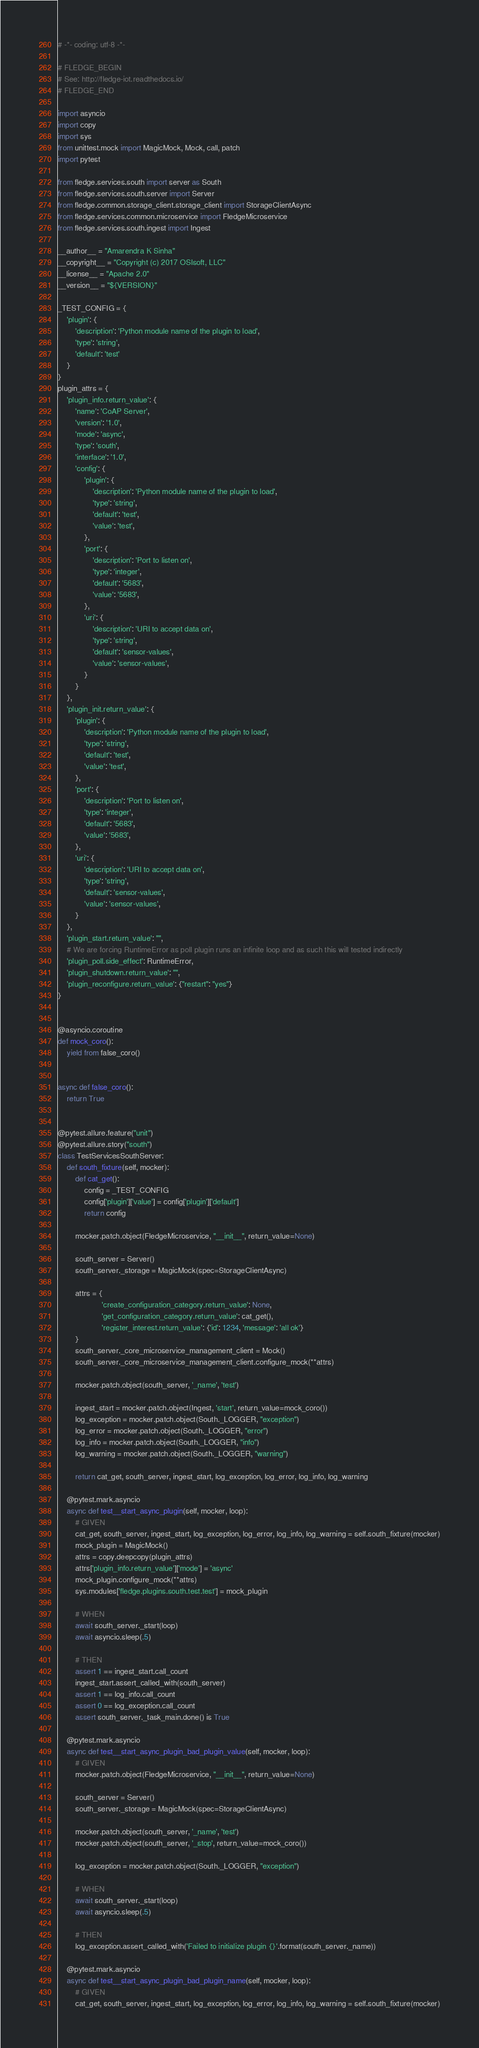Convert code to text. <code><loc_0><loc_0><loc_500><loc_500><_Python_># -*- coding: utf-8 -*-

# FLEDGE_BEGIN
# See: http://fledge-iot.readthedocs.io/
# FLEDGE_END

import asyncio
import copy
import sys
from unittest.mock import MagicMock, Mock, call, patch
import pytest

from fledge.services.south import server as South
from fledge.services.south.server import Server
from fledge.common.storage_client.storage_client import StorageClientAsync
from fledge.services.common.microservice import FledgeMicroservice
from fledge.services.south.ingest import Ingest

__author__ = "Amarendra K Sinha"
__copyright__ = "Copyright (c) 2017 OSIsoft, LLC"
__license__ = "Apache 2.0"
__version__ = "${VERSION}"

_TEST_CONFIG = {
    'plugin': {
        'description': 'Python module name of the plugin to load',
        'type': 'string',
        'default': 'test'
    }
}
plugin_attrs = {
    'plugin_info.return_value': {
        'name': 'CoAP Server',
        'version': '1.0',
        'mode': 'async',
        'type': 'south',
        'interface': '1.0',
        'config': {
            'plugin': {
                'description': 'Python module name of the plugin to load',
                'type': 'string',
                'default': 'test',
                'value': 'test',
            },
            'port': {
                'description': 'Port to listen on',
                'type': 'integer',
                'default': '5683',
                'value': '5683',
            },
            'uri': {
                'description': 'URI to accept data on',
                'type': 'string',
                'default': 'sensor-values',
                'value': 'sensor-values',
            }
        }
    },
    'plugin_init.return_value': {
        'plugin': {
            'description': 'Python module name of the plugin to load',
            'type': 'string',
            'default': 'test',
            'value': 'test',
        },
        'port': {
            'description': 'Port to listen on',
            'type': 'integer',
            'default': '5683',
            'value': '5683',
        },
        'uri': {
            'description': 'URI to accept data on',
            'type': 'string',
            'default': 'sensor-values',
            'value': 'sensor-values',
        }
    },
    'plugin_start.return_value': "",
    # We are forcing RuntimeError as poll plugin runs an infinite loop and as such this will tested indirectly
    'plugin_poll.side_effect': RuntimeError,
    'plugin_shutdown.return_value': "",
    'plugin_reconfigure.return_value': {"restart": "yes"}
}


@asyncio.coroutine
def mock_coro():
    yield from false_coro()


async def false_coro():
    return True


@pytest.allure.feature("unit")
@pytest.allure.story("south")
class TestServicesSouthServer:
    def south_fixture(self, mocker):
        def cat_get():
            config = _TEST_CONFIG
            config['plugin']['value'] = config['plugin']['default']
            return config

        mocker.patch.object(FledgeMicroservice, "__init__", return_value=None)

        south_server = Server()
        south_server._storage = MagicMock(spec=StorageClientAsync)

        attrs = {
                    'create_configuration_category.return_value': None,
                    'get_configuration_category.return_value': cat_get(),
                    'register_interest.return_value': {'id': 1234, 'message': 'all ok'}
        }
        south_server._core_microservice_management_client = Mock()
        south_server._core_microservice_management_client.configure_mock(**attrs)

        mocker.patch.object(south_server, '_name', 'test')

        ingest_start = mocker.patch.object(Ingest, 'start', return_value=mock_coro())
        log_exception = mocker.patch.object(South._LOGGER, "exception")
        log_error = mocker.patch.object(South._LOGGER, "error")
        log_info = mocker.patch.object(South._LOGGER, "info")
        log_warning = mocker.patch.object(South._LOGGER, "warning")

        return cat_get, south_server, ingest_start, log_exception, log_error, log_info, log_warning

    @pytest.mark.asyncio
    async def test__start_async_plugin(self, mocker, loop):
        # GIVEN
        cat_get, south_server, ingest_start, log_exception, log_error, log_info, log_warning = self.south_fixture(mocker)
        mock_plugin = MagicMock()
        attrs = copy.deepcopy(plugin_attrs)
        attrs['plugin_info.return_value']['mode'] = 'async'
        mock_plugin.configure_mock(**attrs)
        sys.modules['fledge.plugins.south.test.test'] = mock_plugin

        # WHEN
        await south_server._start(loop)
        await asyncio.sleep(.5)

        # THEN
        assert 1 == ingest_start.call_count
        ingest_start.assert_called_with(south_server)
        assert 1 == log_info.call_count
        assert 0 == log_exception.call_count
        assert south_server._task_main.done() is True

    @pytest.mark.asyncio
    async def test__start_async_plugin_bad_plugin_value(self, mocker, loop):
        # GIVEN
        mocker.patch.object(FledgeMicroservice, "__init__", return_value=None)

        south_server = Server()
        south_server._storage = MagicMock(spec=StorageClientAsync)

        mocker.patch.object(south_server, '_name', 'test')
        mocker.patch.object(south_server, '_stop', return_value=mock_coro())

        log_exception = mocker.patch.object(South._LOGGER, "exception")

        # WHEN
        await south_server._start(loop)
        await asyncio.sleep(.5)

        # THEN
        log_exception.assert_called_with('Failed to initialize plugin {}'.format(south_server._name))

    @pytest.mark.asyncio
    async def test__start_async_plugin_bad_plugin_name(self, mocker, loop):
        # GIVEN
        cat_get, south_server, ingest_start, log_exception, log_error, log_info, log_warning = self.south_fixture(mocker)</code> 